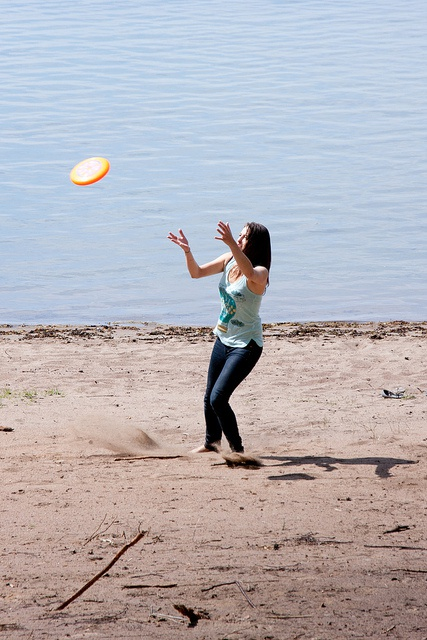Describe the objects in this image and their specific colors. I can see people in lavender, black, gray, lightgray, and lightblue tones and frisbee in lavender, white, khaki, red, and orange tones in this image. 